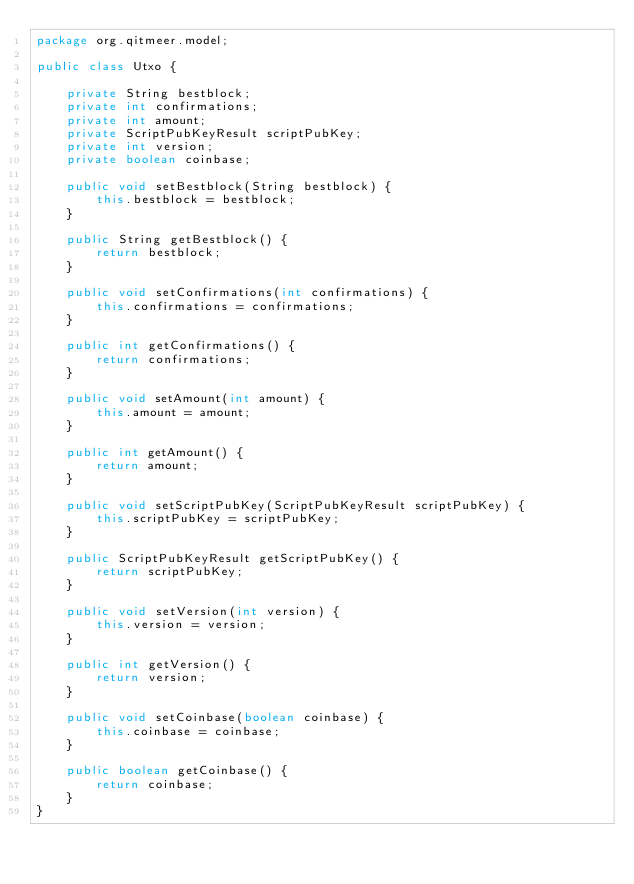<code> <loc_0><loc_0><loc_500><loc_500><_Java_>package org.qitmeer.model;

public class Utxo {

    private String bestblock;
    private int confirmations;
    private int amount;
    private ScriptPubKeyResult scriptPubKey;
    private int version;
    private boolean coinbase;

    public void setBestblock(String bestblock) {
        this.bestblock = bestblock;
    }

    public String getBestblock() {
        return bestblock;
    }

    public void setConfirmations(int confirmations) {
        this.confirmations = confirmations;
    }

    public int getConfirmations() {
        return confirmations;
    }

    public void setAmount(int amount) {
        this.amount = amount;
    }

    public int getAmount() {
        return amount;
    }

    public void setScriptPubKey(ScriptPubKeyResult scriptPubKey) {
        this.scriptPubKey = scriptPubKey;
    }

    public ScriptPubKeyResult getScriptPubKey() {
        return scriptPubKey;
    }

    public void setVersion(int version) {
        this.version = version;
    }

    public int getVersion() {
        return version;
    }

    public void setCoinbase(boolean coinbase) {
        this.coinbase = coinbase;
    }

    public boolean getCoinbase() {
        return coinbase;
    }
}
</code> 